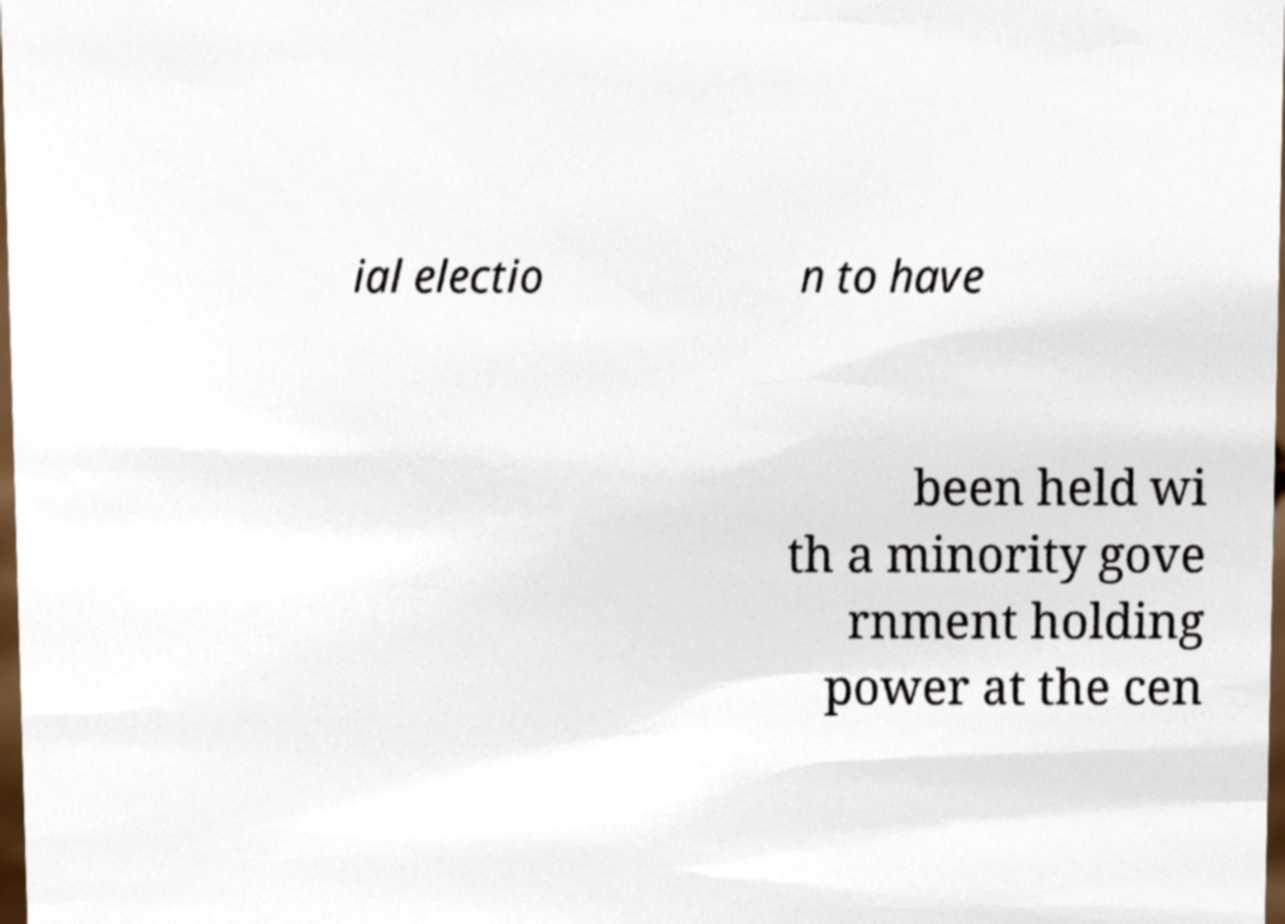Could you extract and type out the text from this image? ial electio n to have been held wi th a minority gove rnment holding power at the cen 